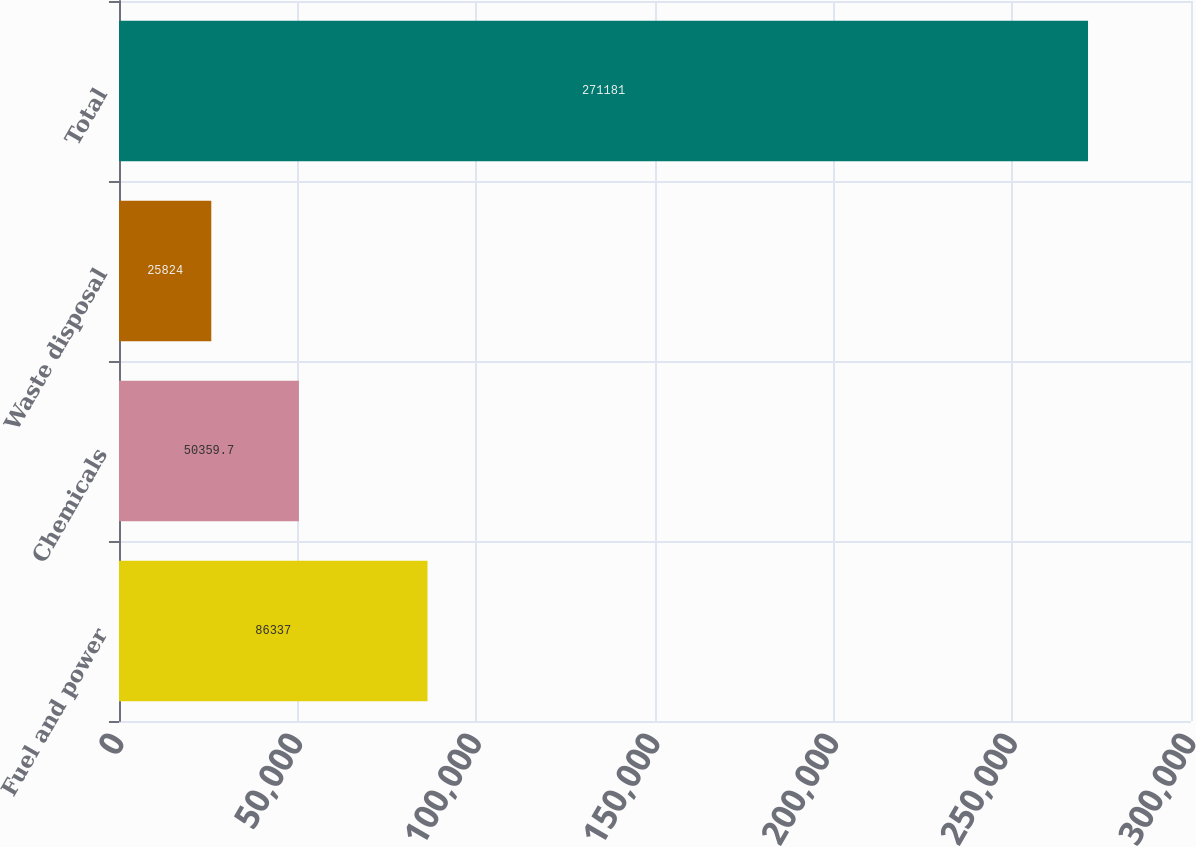Convert chart to OTSL. <chart><loc_0><loc_0><loc_500><loc_500><bar_chart><fcel>Fuel and power<fcel>Chemicals<fcel>Waste disposal<fcel>Total<nl><fcel>86337<fcel>50359.7<fcel>25824<fcel>271181<nl></chart> 